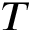Convert formula to latex. <formula><loc_0><loc_0><loc_500><loc_500>T</formula> 